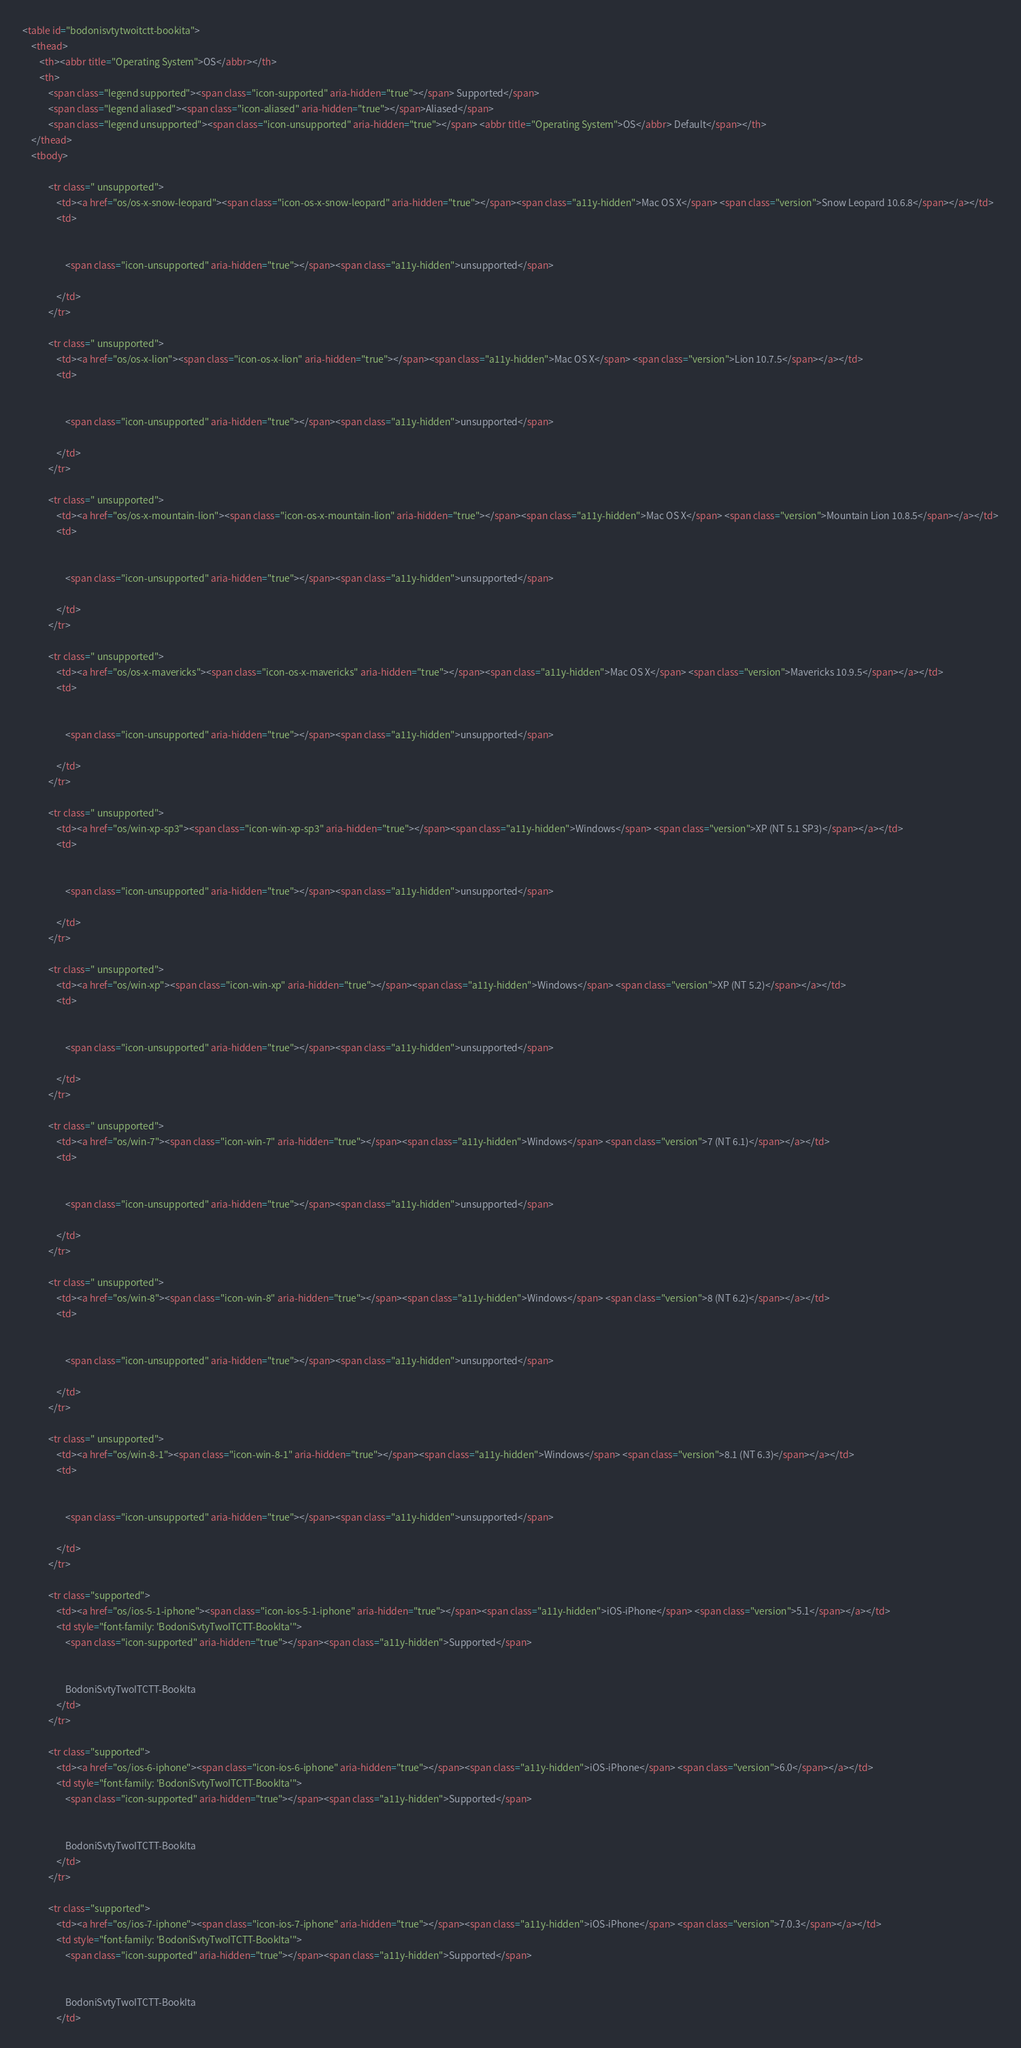<code> <loc_0><loc_0><loc_500><loc_500><_HTML_><table id="bodonisvtytwoitctt-bookita">
	<thead>
		<th><abbr title="Operating System">OS</abbr></th>
		<th>
			<span class="legend supported"><span class="icon-supported" aria-hidden="true"></span> Supported</span>
			<span class="legend aliased"><span class="icon-aliased" aria-hidden="true"></span>Aliased</span>
			<span class="legend unsupported"><span class="icon-unsupported" aria-hidden="true"></span> <abbr title="Operating System">OS</abbr> Default</span></th>
	</thead>
	<tbody>
		
			<tr class=" unsupported">
				<td><a href="os/os-x-snow-leopard"><span class="icon-os-x-snow-leopard" aria-hidden="true"></span><span class="a11y-hidden">Mac OS X</span> <span class="version">Snow Leopard 10.6.8</span></a></td>
				<td>
					
					
					<span class="icon-unsupported" aria-hidden="true"></span><span class="a11y-hidden">unsupported</span>
					
				</td>
			</tr>
		
			<tr class=" unsupported">
				<td><a href="os/os-x-lion"><span class="icon-os-x-lion" aria-hidden="true"></span><span class="a11y-hidden">Mac OS X</span> <span class="version">Lion 10.7.5</span></a></td>
				<td>
					
					
					<span class="icon-unsupported" aria-hidden="true"></span><span class="a11y-hidden">unsupported</span>
					
				</td>
			</tr>
		
			<tr class=" unsupported">
				<td><a href="os/os-x-mountain-lion"><span class="icon-os-x-mountain-lion" aria-hidden="true"></span><span class="a11y-hidden">Mac OS X</span> <span class="version">Mountain Lion 10.8.5</span></a></td>
				<td>
					
					
					<span class="icon-unsupported" aria-hidden="true"></span><span class="a11y-hidden">unsupported</span>
					
				</td>
			</tr>
		
			<tr class=" unsupported">
				<td><a href="os/os-x-mavericks"><span class="icon-os-x-mavericks" aria-hidden="true"></span><span class="a11y-hidden">Mac OS X</span> <span class="version">Mavericks 10.9.5</span></a></td>
				<td>
					
					
					<span class="icon-unsupported" aria-hidden="true"></span><span class="a11y-hidden">unsupported</span>
					
				</td>
			</tr>
		
			<tr class=" unsupported">
				<td><a href="os/win-xp-sp3"><span class="icon-win-xp-sp3" aria-hidden="true"></span><span class="a11y-hidden">Windows</span> <span class="version">XP (NT 5.1 SP3)</span></a></td>
				<td>
					
					
					<span class="icon-unsupported" aria-hidden="true"></span><span class="a11y-hidden">unsupported</span>
					
				</td>
			</tr>
		
			<tr class=" unsupported">
				<td><a href="os/win-xp"><span class="icon-win-xp" aria-hidden="true"></span><span class="a11y-hidden">Windows</span> <span class="version">XP (NT 5.2)</span></a></td>
				<td>
					
					
					<span class="icon-unsupported" aria-hidden="true"></span><span class="a11y-hidden">unsupported</span>
					
				</td>
			</tr>
		
			<tr class=" unsupported">
				<td><a href="os/win-7"><span class="icon-win-7" aria-hidden="true"></span><span class="a11y-hidden">Windows</span> <span class="version">7 (NT 6.1)</span></a></td>
				<td>
					
					
					<span class="icon-unsupported" aria-hidden="true"></span><span class="a11y-hidden">unsupported</span>
					
				</td>
			</tr>
		
			<tr class=" unsupported">
				<td><a href="os/win-8"><span class="icon-win-8" aria-hidden="true"></span><span class="a11y-hidden">Windows</span> <span class="version">8 (NT 6.2)</span></a></td>
				<td>
					
					
					<span class="icon-unsupported" aria-hidden="true"></span><span class="a11y-hidden">unsupported</span>
					
				</td>
			</tr>
		
			<tr class=" unsupported">
				<td><a href="os/win-8-1"><span class="icon-win-8-1" aria-hidden="true"></span><span class="a11y-hidden">Windows</span> <span class="version">8.1 (NT 6.3)</span></a></td>
				<td>
					
					
					<span class="icon-unsupported" aria-hidden="true"></span><span class="a11y-hidden">unsupported</span>
					
				</td>
			</tr>
		
			<tr class="supported">
				<td><a href="os/ios-5-1-iphone"><span class="icon-ios-5-1-iphone" aria-hidden="true"></span><span class="a11y-hidden">iOS-iPhone</span> <span class="version">5.1</span></a></td>
				<td style="font-family: 'BodoniSvtyTwoITCTT-BookIta'">
					<span class="icon-supported" aria-hidden="true"></span><span class="a11y-hidden">Supported</span>
					
					
					BodoniSvtyTwoITCTT-BookIta
				</td>
			</tr>
		
			<tr class="supported">
				<td><a href="os/ios-6-iphone"><span class="icon-ios-6-iphone" aria-hidden="true"></span><span class="a11y-hidden">iOS-iPhone</span> <span class="version">6.0</span></a></td>
				<td style="font-family: 'BodoniSvtyTwoITCTT-BookIta'">
					<span class="icon-supported" aria-hidden="true"></span><span class="a11y-hidden">Supported</span>
					
					
					BodoniSvtyTwoITCTT-BookIta
				</td>
			</tr>
		
			<tr class="supported">
				<td><a href="os/ios-7-iphone"><span class="icon-ios-7-iphone" aria-hidden="true"></span><span class="a11y-hidden">iOS-iPhone</span> <span class="version">7.0.3</span></a></td>
				<td style="font-family: 'BodoniSvtyTwoITCTT-BookIta'">
					<span class="icon-supported" aria-hidden="true"></span><span class="a11y-hidden">Supported</span>
					
					
					BodoniSvtyTwoITCTT-BookIta
				</td></code> 